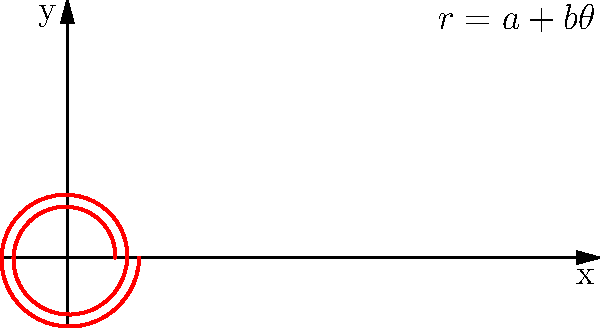As a singer-songwriter blending country and hip-hop, you're fascinated by the spiral pattern on vinyl records. If the groove of a record follows the polar equation $r = 0.2 + 0.05\theta/(2\pi)$, where $r$ is in inches and $\theta$ is in radians, what is the total length of the groove for two full rotations around the center? To find the length of the spiral groove, we'll use the arc length formula for polar curves:

$$ L = \int_a^b \sqrt{r^2 + \left(\frac{dr}{d\theta}\right)^2} d\theta $$

1) First, we need to find $\frac{dr}{d\theta}$:
   $r = 0.2 + 0.05\theta/(2\pi)$
   $\frac{dr}{d\theta} = 0.05/(2\pi) = 0.025/\pi$

2) Now, let's substitute into the arc length formula:
   $$ L = \int_0^{4\pi} \sqrt{(0.2 + 0.05\theta/(2\pi))^2 + (0.025/\pi)^2} d\theta $$

3) This integral is complex to solve analytically, so we'll use numerical integration.

4) Using a computational tool (like Python with SciPy), we can evaluate this integral:
   $$ L \approx 2.5133 \text{ inches} $$

5) Rounding to three decimal places:
   $$ L \approx 2.513 \text{ inches} $$

This length represents the total distance the needle would travel for two full rotations around the center of the record.
Answer: 2.513 inches 